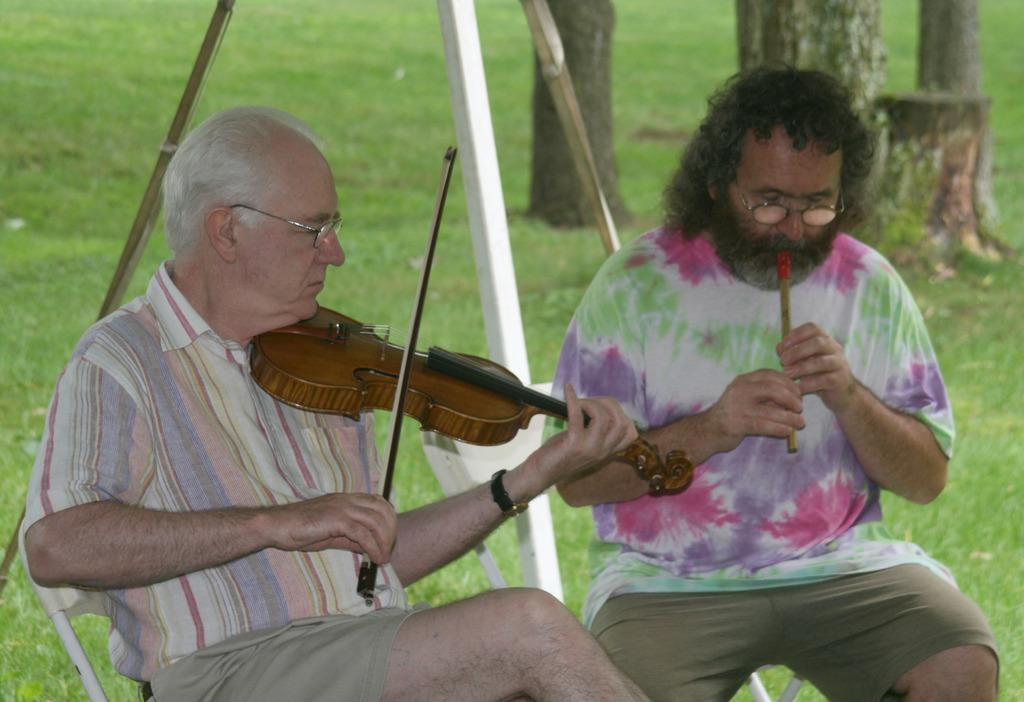What are the people in the image doing? The people in the image are playing musical instruments. What are the people sitting on while playing their instruments? The people are sitting on chairs in the image. What type of surface is visible beneath the chairs? The ground is covered with grass. What type of wire can be seen connecting the musical instruments in the image? There is no wire connecting the musical instruments in the image; they are being played by people sitting on chairs. 